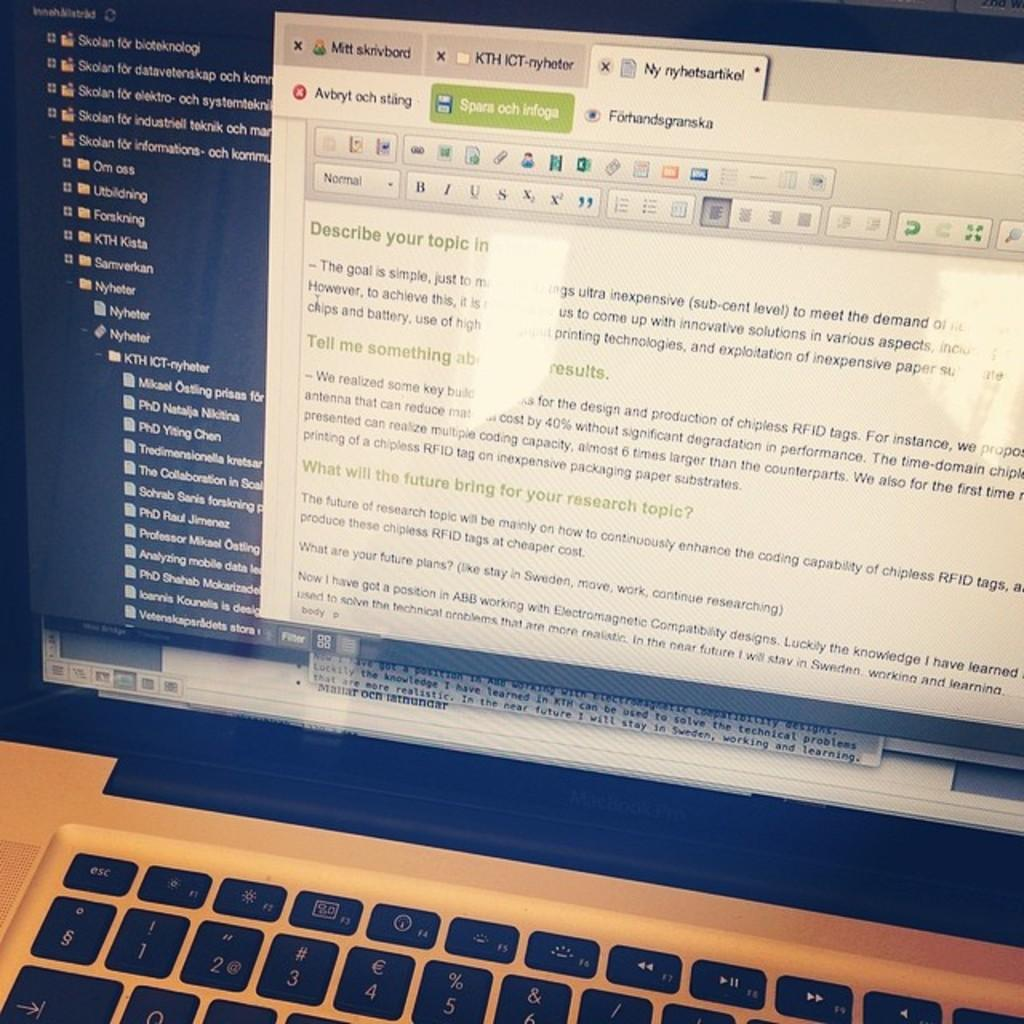<image>
Summarize the visual content of the image. The first title in green color on the screen says "Describe your topic in." 